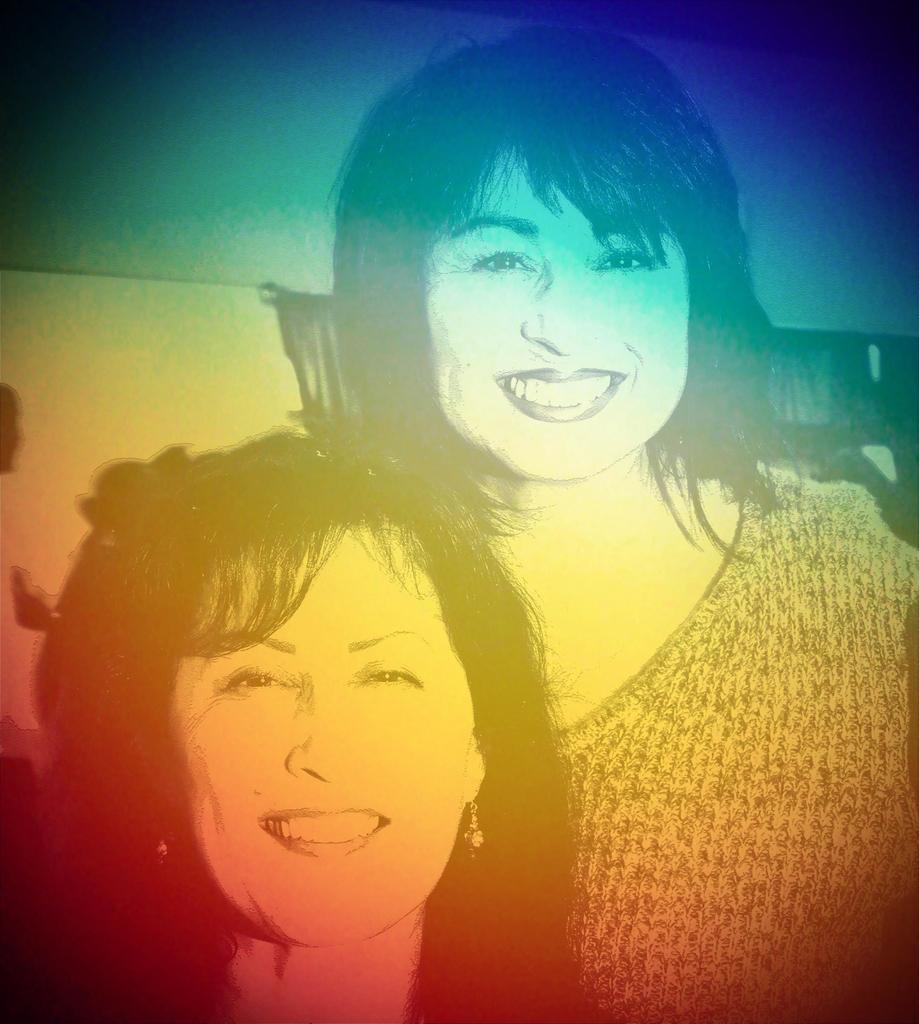Could you give a brief overview of what you see in this image? In the picture I can see two women and there is a pretty smile on their face. 